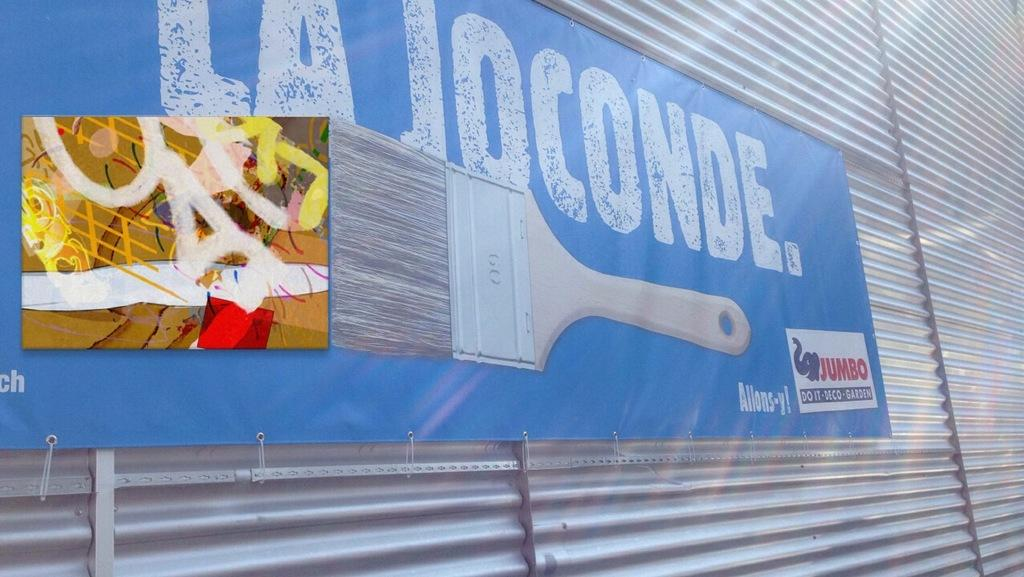<image>
Share a concise interpretation of the image provided. Blue sign that says La Joconde with a paintbrush as well. 